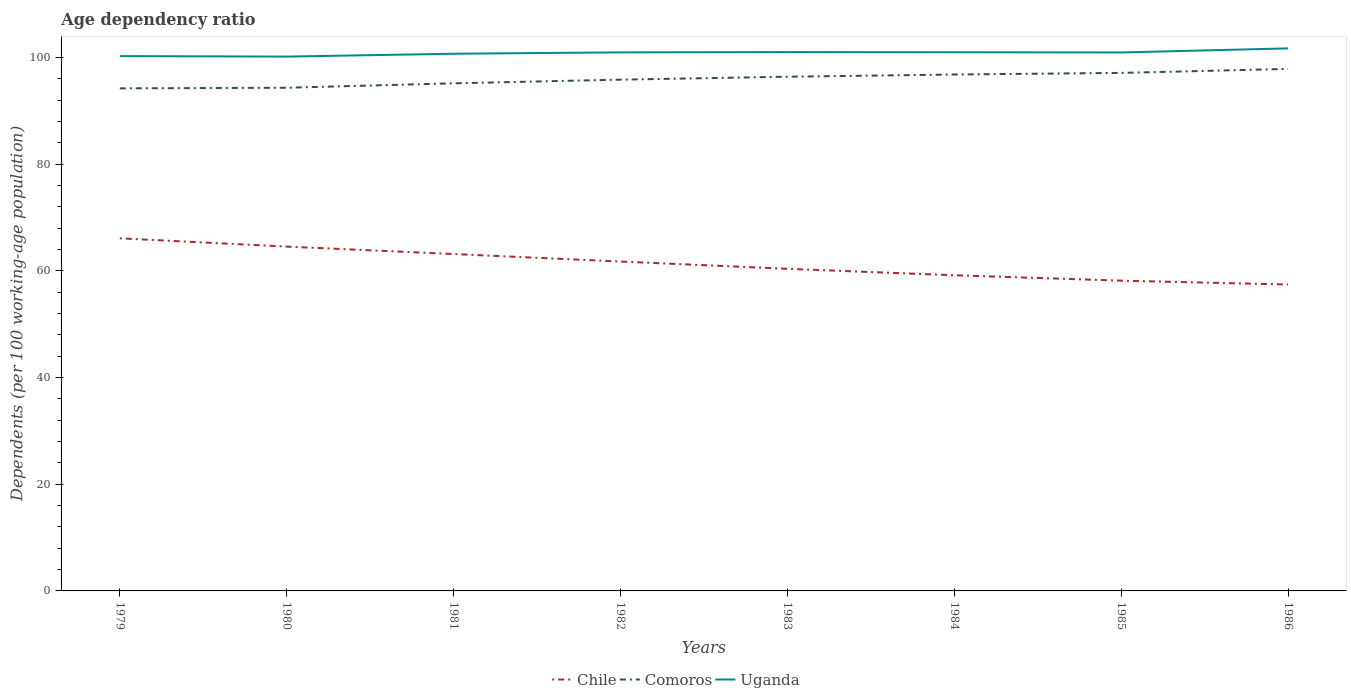Across all years, what is the maximum age dependency ratio in in Comoros?
Provide a succinct answer. 94.24. In which year was the age dependency ratio in in Comoros maximum?
Offer a terse response. 1979. What is the total age dependency ratio in in Chile in the graph?
Your answer should be compact. 4.16. What is the difference between the highest and the second highest age dependency ratio in in Comoros?
Your answer should be very brief. 3.65. How many lines are there?
Make the answer very short. 3. How many years are there in the graph?
Your response must be concise. 8. Does the graph contain grids?
Make the answer very short. No. How many legend labels are there?
Your answer should be very brief. 3. What is the title of the graph?
Make the answer very short. Age dependency ratio. Does "St. Lucia" appear as one of the legend labels in the graph?
Your response must be concise. No. What is the label or title of the X-axis?
Offer a very short reply. Years. What is the label or title of the Y-axis?
Your answer should be compact. Dependents (per 100 working-age population). What is the Dependents (per 100 working-age population) in Chile in 1979?
Your answer should be compact. 66.12. What is the Dependents (per 100 working-age population) of Comoros in 1979?
Keep it short and to the point. 94.24. What is the Dependents (per 100 working-age population) in Uganda in 1979?
Keep it short and to the point. 100.29. What is the Dependents (per 100 working-age population) of Chile in 1980?
Offer a terse response. 64.57. What is the Dependents (per 100 working-age population) in Comoros in 1980?
Keep it short and to the point. 94.36. What is the Dependents (per 100 working-age population) of Uganda in 1980?
Provide a succinct answer. 100.2. What is the Dependents (per 100 working-age population) of Chile in 1981?
Provide a short and direct response. 63.17. What is the Dependents (per 100 working-age population) of Comoros in 1981?
Your response must be concise. 95.18. What is the Dependents (per 100 working-age population) in Uganda in 1981?
Offer a terse response. 100.73. What is the Dependents (per 100 working-age population) of Chile in 1982?
Offer a terse response. 61.76. What is the Dependents (per 100 working-age population) of Comoros in 1982?
Provide a succinct answer. 95.87. What is the Dependents (per 100 working-age population) in Uganda in 1982?
Offer a very short reply. 100.99. What is the Dependents (per 100 working-age population) of Chile in 1983?
Ensure brevity in your answer.  60.4. What is the Dependents (per 100 working-age population) of Comoros in 1983?
Your answer should be very brief. 96.42. What is the Dependents (per 100 working-age population) in Uganda in 1983?
Your answer should be compact. 101.04. What is the Dependents (per 100 working-age population) in Chile in 1984?
Provide a short and direct response. 59.19. What is the Dependents (per 100 working-age population) in Comoros in 1984?
Provide a short and direct response. 96.84. What is the Dependents (per 100 working-age population) of Uganda in 1984?
Your answer should be compact. 101.01. What is the Dependents (per 100 working-age population) in Chile in 1985?
Keep it short and to the point. 58.18. What is the Dependents (per 100 working-age population) in Comoros in 1985?
Make the answer very short. 97.14. What is the Dependents (per 100 working-age population) in Uganda in 1985?
Your answer should be very brief. 100.97. What is the Dependents (per 100 working-age population) in Chile in 1986?
Ensure brevity in your answer.  57.46. What is the Dependents (per 100 working-age population) of Comoros in 1986?
Your response must be concise. 97.89. What is the Dependents (per 100 working-age population) in Uganda in 1986?
Offer a very short reply. 101.74. Across all years, what is the maximum Dependents (per 100 working-age population) in Chile?
Your answer should be compact. 66.12. Across all years, what is the maximum Dependents (per 100 working-age population) in Comoros?
Ensure brevity in your answer.  97.89. Across all years, what is the maximum Dependents (per 100 working-age population) of Uganda?
Ensure brevity in your answer.  101.74. Across all years, what is the minimum Dependents (per 100 working-age population) in Chile?
Keep it short and to the point. 57.46. Across all years, what is the minimum Dependents (per 100 working-age population) in Comoros?
Provide a short and direct response. 94.24. Across all years, what is the minimum Dependents (per 100 working-age population) in Uganda?
Provide a succinct answer. 100.2. What is the total Dependents (per 100 working-age population) in Chile in the graph?
Ensure brevity in your answer.  490.86. What is the total Dependents (per 100 working-age population) of Comoros in the graph?
Provide a succinct answer. 767.94. What is the total Dependents (per 100 working-age population) in Uganda in the graph?
Ensure brevity in your answer.  806.98. What is the difference between the Dependents (per 100 working-age population) in Chile in 1979 and that in 1980?
Provide a succinct answer. 1.55. What is the difference between the Dependents (per 100 working-age population) in Comoros in 1979 and that in 1980?
Ensure brevity in your answer.  -0.12. What is the difference between the Dependents (per 100 working-age population) of Uganda in 1979 and that in 1980?
Make the answer very short. 0.09. What is the difference between the Dependents (per 100 working-age population) of Chile in 1979 and that in 1981?
Offer a terse response. 2.95. What is the difference between the Dependents (per 100 working-age population) in Comoros in 1979 and that in 1981?
Give a very brief answer. -0.95. What is the difference between the Dependents (per 100 working-age population) of Uganda in 1979 and that in 1981?
Your answer should be very brief. -0.44. What is the difference between the Dependents (per 100 working-age population) of Chile in 1979 and that in 1982?
Ensure brevity in your answer.  4.35. What is the difference between the Dependents (per 100 working-age population) in Comoros in 1979 and that in 1982?
Provide a short and direct response. -1.64. What is the difference between the Dependents (per 100 working-age population) of Uganda in 1979 and that in 1982?
Provide a succinct answer. -0.7. What is the difference between the Dependents (per 100 working-age population) in Chile in 1979 and that in 1983?
Keep it short and to the point. 5.72. What is the difference between the Dependents (per 100 working-age population) in Comoros in 1979 and that in 1983?
Your answer should be very brief. -2.18. What is the difference between the Dependents (per 100 working-age population) of Uganda in 1979 and that in 1983?
Ensure brevity in your answer.  -0.75. What is the difference between the Dependents (per 100 working-age population) in Chile in 1979 and that in 1984?
Make the answer very short. 6.93. What is the difference between the Dependents (per 100 working-age population) of Comoros in 1979 and that in 1984?
Your answer should be compact. -2.6. What is the difference between the Dependents (per 100 working-age population) in Uganda in 1979 and that in 1984?
Your response must be concise. -0.72. What is the difference between the Dependents (per 100 working-age population) in Chile in 1979 and that in 1985?
Make the answer very short. 7.94. What is the difference between the Dependents (per 100 working-age population) of Comoros in 1979 and that in 1985?
Your answer should be compact. -2.9. What is the difference between the Dependents (per 100 working-age population) of Uganda in 1979 and that in 1985?
Offer a terse response. -0.68. What is the difference between the Dependents (per 100 working-age population) in Chile in 1979 and that in 1986?
Keep it short and to the point. 8.66. What is the difference between the Dependents (per 100 working-age population) in Comoros in 1979 and that in 1986?
Your answer should be very brief. -3.65. What is the difference between the Dependents (per 100 working-age population) in Uganda in 1979 and that in 1986?
Ensure brevity in your answer.  -1.44. What is the difference between the Dependents (per 100 working-age population) in Chile in 1980 and that in 1981?
Provide a short and direct response. 1.39. What is the difference between the Dependents (per 100 working-age population) in Comoros in 1980 and that in 1981?
Your answer should be compact. -0.83. What is the difference between the Dependents (per 100 working-age population) in Uganda in 1980 and that in 1981?
Make the answer very short. -0.54. What is the difference between the Dependents (per 100 working-age population) in Chile in 1980 and that in 1982?
Your answer should be compact. 2.8. What is the difference between the Dependents (per 100 working-age population) in Comoros in 1980 and that in 1982?
Make the answer very short. -1.52. What is the difference between the Dependents (per 100 working-age population) of Uganda in 1980 and that in 1982?
Offer a very short reply. -0.79. What is the difference between the Dependents (per 100 working-age population) in Chile in 1980 and that in 1983?
Provide a short and direct response. 4.16. What is the difference between the Dependents (per 100 working-age population) of Comoros in 1980 and that in 1983?
Provide a short and direct response. -2.07. What is the difference between the Dependents (per 100 working-age population) in Uganda in 1980 and that in 1983?
Ensure brevity in your answer.  -0.85. What is the difference between the Dependents (per 100 working-age population) of Chile in 1980 and that in 1984?
Make the answer very short. 5.38. What is the difference between the Dependents (per 100 working-age population) in Comoros in 1980 and that in 1984?
Give a very brief answer. -2.48. What is the difference between the Dependents (per 100 working-age population) in Uganda in 1980 and that in 1984?
Offer a terse response. -0.81. What is the difference between the Dependents (per 100 working-age population) in Chile in 1980 and that in 1985?
Your answer should be very brief. 6.39. What is the difference between the Dependents (per 100 working-age population) in Comoros in 1980 and that in 1985?
Offer a very short reply. -2.78. What is the difference between the Dependents (per 100 working-age population) in Uganda in 1980 and that in 1985?
Offer a very short reply. -0.77. What is the difference between the Dependents (per 100 working-age population) in Chile in 1980 and that in 1986?
Your answer should be compact. 7.11. What is the difference between the Dependents (per 100 working-age population) of Comoros in 1980 and that in 1986?
Make the answer very short. -3.53. What is the difference between the Dependents (per 100 working-age population) in Uganda in 1980 and that in 1986?
Give a very brief answer. -1.54. What is the difference between the Dependents (per 100 working-age population) in Chile in 1981 and that in 1982?
Offer a terse response. 1.41. What is the difference between the Dependents (per 100 working-age population) of Comoros in 1981 and that in 1982?
Your response must be concise. -0.69. What is the difference between the Dependents (per 100 working-age population) in Uganda in 1981 and that in 1982?
Provide a short and direct response. -0.25. What is the difference between the Dependents (per 100 working-age population) of Chile in 1981 and that in 1983?
Offer a terse response. 2.77. What is the difference between the Dependents (per 100 working-age population) of Comoros in 1981 and that in 1983?
Offer a terse response. -1.24. What is the difference between the Dependents (per 100 working-age population) of Uganda in 1981 and that in 1983?
Give a very brief answer. -0.31. What is the difference between the Dependents (per 100 working-age population) of Chile in 1981 and that in 1984?
Offer a very short reply. 3.98. What is the difference between the Dependents (per 100 working-age population) in Comoros in 1981 and that in 1984?
Offer a very short reply. -1.65. What is the difference between the Dependents (per 100 working-age population) of Uganda in 1981 and that in 1984?
Provide a succinct answer. -0.28. What is the difference between the Dependents (per 100 working-age population) in Chile in 1981 and that in 1985?
Offer a very short reply. 4.99. What is the difference between the Dependents (per 100 working-age population) in Comoros in 1981 and that in 1985?
Your response must be concise. -1.95. What is the difference between the Dependents (per 100 working-age population) of Uganda in 1981 and that in 1985?
Your response must be concise. -0.24. What is the difference between the Dependents (per 100 working-age population) in Chile in 1981 and that in 1986?
Your response must be concise. 5.72. What is the difference between the Dependents (per 100 working-age population) in Comoros in 1981 and that in 1986?
Provide a short and direct response. -2.7. What is the difference between the Dependents (per 100 working-age population) in Uganda in 1981 and that in 1986?
Keep it short and to the point. -1. What is the difference between the Dependents (per 100 working-age population) of Chile in 1982 and that in 1983?
Your answer should be compact. 1.36. What is the difference between the Dependents (per 100 working-age population) of Comoros in 1982 and that in 1983?
Give a very brief answer. -0.55. What is the difference between the Dependents (per 100 working-age population) of Uganda in 1982 and that in 1983?
Give a very brief answer. -0.06. What is the difference between the Dependents (per 100 working-age population) in Chile in 1982 and that in 1984?
Provide a short and direct response. 2.57. What is the difference between the Dependents (per 100 working-age population) of Comoros in 1982 and that in 1984?
Provide a succinct answer. -0.97. What is the difference between the Dependents (per 100 working-age population) in Uganda in 1982 and that in 1984?
Ensure brevity in your answer.  -0.02. What is the difference between the Dependents (per 100 working-age population) of Chile in 1982 and that in 1985?
Your response must be concise. 3.58. What is the difference between the Dependents (per 100 working-age population) in Comoros in 1982 and that in 1985?
Provide a short and direct response. -1.27. What is the difference between the Dependents (per 100 working-age population) of Uganda in 1982 and that in 1985?
Provide a succinct answer. 0.02. What is the difference between the Dependents (per 100 working-age population) of Chile in 1982 and that in 1986?
Make the answer very short. 4.31. What is the difference between the Dependents (per 100 working-age population) of Comoros in 1982 and that in 1986?
Your answer should be very brief. -2.01. What is the difference between the Dependents (per 100 working-age population) in Uganda in 1982 and that in 1986?
Offer a very short reply. -0.75. What is the difference between the Dependents (per 100 working-age population) in Chile in 1983 and that in 1984?
Ensure brevity in your answer.  1.21. What is the difference between the Dependents (per 100 working-age population) of Comoros in 1983 and that in 1984?
Offer a very short reply. -0.42. What is the difference between the Dependents (per 100 working-age population) in Uganda in 1983 and that in 1984?
Your answer should be compact. 0.03. What is the difference between the Dependents (per 100 working-age population) in Chile in 1983 and that in 1985?
Keep it short and to the point. 2.22. What is the difference between the Dependents (per 100 working-age population) of Comoros in 1983 and that in 1985?
Keep it short and to the point. -0.72. What is the difference between the Dependents (per 100 working-age population) of Uganda in 1983 and that in 1985?
Your answer should be very brief. 0.07. What is the difference between the Dependents (per 100 working-age population) in Chile in 1983 and that in 1986?
Offer a very short reply. 2.95. What is the difference between the Dependents (per 100 working-age population) of Comoros in 1983 and that in 1986?
Ensure brevity in your answer.  -1.47. What is the difference between the Dependents (per 100 working-age population) of Uganda in 1983 and that in 1986?
Your answer should be very brief. -0.69. What is the difference between the Dependents (per 100 working-age population) of Chile in 1984 and that in 1985?
Your response must be concise. 1.01. What is the difference between the Dependents (per 100 working-age population) of Comoros in 1984 and that in 1985?
Make the answer very short. -0.3. What is the difference between the Dependents (per 100 working-age population) in Uganda in 1984 and that in 1985?
Give a very brief answer. 0.04. What is the difference between the Dependents (per 100 working-age population) of Chile in 1984 and that in 1986?
Provide a short and direct response. 1.73. What is the difference between the Dependents (per 100 working-age population) of Comoros in 1984 and that in 1986?
Offer a very short reply. -1.05. What is the difference between the Dependents (per 100 working-age population) of Uganda in 1984 and that in 1986?
Make the answer very short. -0.72. What is the difference between the Dependents (per 100 working-age population) of Chile in 1985 and that in 1986?
Ensure brevity in your answer.  0.72. What is the difference between the Dependents (per 100 working-age population) in Comoros in 1985 and that in 1986?
Make the answer very short. -0.75. What is the difference between the Dependents (per 100 working-age population) of Uganda in 1985 and that in 1986?
Give a very brief answer. -0.76. What is the difference between the Dependents (per 100 working-age population) in Chile in 1979 and the Dependents (per 100 working-age population) in Comoros in 1980?
Ensure brevity in your answer.  -28.24. What is the difference between the Dependents (per 100 working-age population) of Chile in 1979 and the Dependents (per 100 working-age population) of Uganda in 1980?
Your answer should be compact. -34.08. What is the difference between the Dependents (per 100 working-age population) of Comoros in 1979 and the Dependents (per 100 working-age population) of Uganda in 1980?
Your answer should be compact. -5.96. What is the difference between the Dependents (per 100 working-age population) of Chile in 1979 and the Dependents (per 100 working-age population) of Comoros in 1981?
Keep it short and to the point. -29.07. What is the difference between the Dependents (per 100 working-age population) in Chile in 1979 and the Dependents (per 100 working-age population) in Uganda in 1981?
Offer a very short reply. -34.62. What is the difference between the Dependents (per 100 working-age population) in Comoros in 1979 and the Dependents (per 100 working-age population) in Uganda in 1981?
Give a very brief answer. -6.5. What is the difference between the Dependents (per 100 working-age population) in Chile in 1979 and the Dependents (per 100 working-age population) in Comoros in 1982?
Your answer should be compact. -29.75. What is the difference between the Dependents (per 100 working-age population) in Chile in 1979 and the Dependents (per 100 working-age population) in Uganda in 1982?
Provide a succinct answer. -34.87. What is the difference between the Dependents (per 100 working-age population) of Comoros in 1979 and the Dependents (per 100 working-age population) of Uganda in 1982?
Your answer should be compact. -6.75. What is the difference between the Dependents (per 100 working-age population) of Chile in 1979 and the Dependents (per 100 working-age population) of Comoros in 1983?
Provide a succinct answer. -30.3. What is the difference between the Dependents (per 100 working-age population) in Chile in 1979 and the Dependents (per 100 working-age population) in Uganda in 1983?
Your response must be concise. -34.92. What is the difference between the Dependents (per 100 working-age population) of Comoros in 1979 and the Dependents (per 100 working-age population) of Uganda in 1983?
Offer a terse response. -6.81. What is the difference between the Dependents (per 100 working-age population) of Chile in 1979 and the Dependents (per 100 working-age population) of Comoros in 1984?
Make the answer very short. -30.72. What is the difference between the Dependents (per 100 working-age population) in Chile in 1979 and the Dependents (per 100 working-age population) in Uganda in 1984?
Make the answer very short. -34.89. What is the difference between the Dependents (per 100 working-age population) of Comoros in 1979 and the Dependents (per 100 working-age population) of Uganda in 1984?
Give a very brief answer. -6.77. What is the difference between the Dependents (per 100 working-age population) of Chile in 1979 and the Dependents (per 100 working-age population) of Comoros in 1985?
Keep it short and to the point. -31.02. What is the difference between the Dependents (per 100 working-age population) of Chile in 1979 and the Dependents (per 100 working-age population) of Uganda in 1985?
Offer a very short reply. -34.85. What is the difference between the Dependents (per 100 working-age population) in Comoros in 1979 and the Dependents (per 100 working-age population) in Uganda in 1985?
Give a very brief answer. -6.73. What is the difference between the Dependents (per 100 working-age population) in Chile in 1979 and the Dependents (per 100 working-age population) in Comoros in 1986?
Make the answer very short. -31.77. What is the difference between the Dependents (per 100 working-age population) in Chile in 1979 and the Dependents (per 100 working-age population) in Uganda in 1986?
Offer a terse response. -35.62. What is the difference between the Dependents (per 100 working-age population) in Comoros in 1979 and the Dependents (per 100 working-age population) in Uganda in 1986?
Ensure brevity in your answer.  -7.5. What is the difference between the Dependents (per 100 working-age population) in Chile in 1980 and the Dependents (per 100 working-age population) in Comoros in 1981?
Your answer should be compact. -30.62. What is the difference between the Dependents (per 100 working-age population) in Chile in 1980 and the Dependents (per 100 working-age population) in Uganda in 1981?
Ensure brevity in your answer.  -36.17. What is the difference between the Dependents (per 100 working-age population) in Comoros in 1980 and the Dependents (per 100 working-age population) in Uganda in 1981?
Your answer should be very brief. -6.38. What is the difference between the Dependents (per 100 working-age population) in Chile in 1980 and the Dependents (per 100 working-age population) in Comoros in 1982?
Provide a short and direct response. -31.31. What is the difference between the Dependents (per 100 working-age population) of Chile in 1980 and the Dependents (per 100 working-age population) of Uganda in 1982?
Make the answer very short. -36.42. What is the difference between the Dependents (per 100 working-age population) in Comoros in 1980 and the Dependents (per 100 working-age population) in Uganda in 1982?
Your response must be concise. -6.63. What is the difference between the Dependents (per 100 working-age population) of Chile in 1980 and the Dependents (per 100 working-age population) of Comoros in 1983?
Offer a terse response. -31.85. What is the difference between the Dependents (per 100 working-age population) of Chile in 1980 and the Dependents (per 100 working-age population) of Uganda in 1983?
Make the answer very short. -36.48. What is the difference between the Dependents (per 100 working-age population) in Comoros in 1980 and the Dependents (per 100 working-age population) in Uganda in 1983?
Your response must be concise. -6.69. What is the difference between the Dependents (per 100 working-age population) of Chile in 1980 and the Dependents (per 100 working-age population) of Comoros in 1984?
Give a very brief answer. -32.27. What is the difference between the Dependents (per 100 working-age population) in Chile in 1980 and the Dependents (per 100 working-age population) in Uganda in 1984?
Give a very brief answer. -36.44. What is the difference between the Dependents (per 100 working-age population) of Comoros in 1980 and the Dependents (per 100 working-age population) of Uganda in 1984?
Provide a short and direct response. -6.66. What is the difference between the Dependents (per 100 working-age population) in Chile in 1980 and the Dependents (per 100 working-age population) in Comoros in 1985?
Make the answer very short. -32.57. What is the difference between the Dependents (per 100 working-age population) of Chile in 1980 and the Dependents (per 100 working-age population) of Uganda in 1985?
Your answer should be compact. -36.4. What is the difference between the Dependents (per 100 working-age population) of Comoros in 1980 and the Dependents (per 100 working-age population) of Uganda in 1985?
Provide a short and direct response. -6.62. What is the difference between the Dependents (per 100 working-age population) in Chile in 1980 and the Dependents (per 100 working-age population) in Comoros in 1986?
Ensure brevity in your answer.  -33.32. What is the difference between the Dependents (per 100 working-age population) of Chile in 1980 and the Dependents (per 100 working-age population) of Uganda in 1986?
Keep it short and to the point. -37.17. What is the difference between the Dependents (per 100 working-age population) of Comoros in 1980 and the Dependents (per 100 working-age population) of Uganda in 1986?
Give a very brief answer. -7.38. What is the difference between the Dependents (per 100 working-age population) of Chile in 1981 and the Dependents (per 100 working-age population) of Comoros in 1982?
Your answer should be compact. -32.7. What is the difference between the Dependents (per 100 working-age population) of Chile in 1981 and the Dependents (per 100 working-age population) of Uganda in 1982?
Offer a very short reply. -37.82. What is the difference between the Dependents (per 100 working-age population) of Comoros in 1981 and the Dependents (per 100 working-age population) of Uganda in 1982?
Ensure brevity in your answer.  -5.8. What is the difference between the Dependents (per 100 working-age population) of Chile in 1981 and the Dependents (per 100 working-age population) of Comoros in 1983?
Your answer should be compact. -33.25. What is the difference between the Dependents (per 100 working-age population) of Chile in 1981 and the Dependents (per 100 working-age population) of Uganda in 1983?
Offer a very short reply. -37.87. What is the difference between the Dependents (per 100 working-age population) in Comoros in 1981 and the Dependents (per 100 working-age population) in Uganda in 1983?
Ensure brevity in your answer.  -5.86. What is the difference between the Dependents (per 100 working-age population) in Chile in 1981 and the Dependents (per 100 working-age population) in Comoros in 1984?
Your answer should be compact. -33.67. What is the difference between the Dependents (per 100 working-age population) in Chile in 1981 and the Dependents (per 100 working-age population) in Uganda in 1984?
Offer a terse response. -37.84. What is the difference between the Dependents (per 100 working-age population) of Comoros in 1981 and the Dependents (per 100 working-age population) of Uganda in 1984?
Keep it short and to the point. -5.83. What is the difference between the Dependents (per 100 working-age population) in Chile in 1981 and the Dependents (per 100 working-age population) in Comoros in 1985?
Ensure brevity in your answer.  -33.97. What is the difference between the Dependents (per 100 working-age population) in Chile in 1981 and the Dependents (per 100 working-age population) in Uganda in 1985?
Keep it short and to the point. -37.8. What is the difference between the Dependents (per 100 working-age population) of Comoros in 1981 and the Dependents (per 100 working-age population) of Uganda in 1985?
Provide a succinct answer. -5.79. What is the difference between the Dependents (per 100 working-age population) in Chile in 1981 and the Dependents (per 100 working-age population) in Comoros in 1986?
Your response must be concise. -34.72. What is the difference between the Dependents (per 100 working-age population) of Chile in 1981 and the Dependents (per 100 working-age population) of Uganda in 1986?
Your response must be concise. -38.56. What is the difference between the Dependents (per 100 working-age population) of Comoros in 1981 and the Dependents (per 100 working-age population) of Uganda in 1986?
Provide a succinct answer. -6.55. What is the difference between the Dependents (per 100 working-age population) in Chile in 1982 and the Dependents (per 100 working-age population) in Comoros in 1983?
Provide a succinct answer. -34.66. What is the difference between the Dependents (per 100 working-age population) of Chile in 1982 and the Dependents (per 100 working-age population) of Uganda in 1983?
Your answer should be very brief. -39.28. What is the difference between the Dependents (per 100 working-age population) in Comoros in 1982 and the Dependents (per 100 working-age population) in Uganda in 1983?
Your response must be concise. -5.17. What is the difference between the Dependents (per 100 working-age population) in Chile in 1982 and the Dependents (per 100 working-age population) in Comoros in 1984?
Provide a succinct answer. -35.07. What is the difference between the Dependents (per 100 working-age population) of Chile in 1982 and the Dependents (per 100 working-age population) of Uganda in 1984?
Ensure brevity in your answer.  -39.25. What is the difference between the Dependents (per 100 working-age population) of Comoros in 1982 and the Dependents (per 100 working-age population) of Uganda in 1984?
Offer a very short reply. -5.14. What is the difference between the Dependents (per 100 working-age population) in Chile in 1982 and the Dependents (per 100 working-age population) in Comoros in 1985?
Provide a short and direct response. -35.37. What is the difference between the Dependents (per 100 working-age population) in Chile in 1982 and the Dependents (per 100 working-age population) in Uganda in 1985?
Your response must be concise. -39.21. What is the difference between the Dependents (per 100 working-age population) of Comoros in 1982 and the Dependents (per 100 working-age population) of Uganda in 1985?
Provide a short and direct response. -5.1. What is the difference between the Dependents (per 100 working-age population) in Chile in 1982 and the Dependents (per 100 working-age population) in Comoros in 1986?
Give a very brief answer. -36.12. What is the difference between the Dependents (per 100 working-age population) of Chile in 1982 and the Dependents (per 100 working-age population) of Uganda in 1986?
Ensure brevity in your answer.  -39.97. What is the difference between the Dependents (per 100 working-age population) in Comoros in 1982 and the Dependents (per 100 working-age population) in Uganda in 1986?
Offer a very short reply. -5.86. What is the difference between the Dependents (per 100 working-age population) of Chile in 1983 and the Dependents (per 100 working-age population) of Comoros in 1984?
Your response must be concise. -36.44. What is the difference between the Dependents (per 100 working-age population) in Chile in 1983 and the Dependents (per 100 working-age population) in Uganda in 1984?
Make the answer very short. -40.61. What is the difference between the Dependents (per 100 working-age population) of Comoros in 1983 and the Dependents (per 100 working-age population) of Uganda in 1984?
Give a very brief answer. -4.59. What is the difference between the Dependents (per 100 working-age population) in Chile in 1983 and the Dependents (per 100 working-age population) in Comoros in 1985?
Offer a very short reply. -36.73. What is the difference between the Dependents (per 100 working-age population) in Chile in 1983 and the Dependents (per 100 working-age population) in Uganda in 1985?
Provide a short and direct response. -40.57. What is the difference between the Dependents (per 100 working-age population) of Comoros in 1983 and the Dependents (per 100 working-age population) of Uganda in 1985?
Ensure brevity in your answer.  -4.55. What is the difference between the Dependents (per 100 working-age population) of Chile in 1983 and the Dependents (per 100 working-age population) of Comoros in 1986?
Ensure brevity in your answer.  -37.48. What is the difference between the Dependents (per 100 working-age population) of Chile in 1983 and the Dependents (per 100 working-age population) of Uganda in 1986?
Offer a terse response. -41.33. What is the difference between the Dependents (per 100 working-age population) of Comoros in 1983 and the Dependents (per 100 working-age population) of Uganda in 1986?
Offer a terse response. -5.31. What is the difference between the Dependents (per 100 working-age population) of Chile in 1984 and the Dependents (per 100 working-age population) of Comoros in 1985?
Your answer should be very brief. -37.95. What is the difference between the Dependents (per 100 working-age population) of Chile in 1984 and the Dependents (per 100 working-age population) of Uganda in 1985?
Give a very brief answer. -41.78. What is the difference between the Dependents (per 100 working-age population) in Comoros in 1984 and the Dependents (per 100 working-age population) in Uganda in 1985?
Provide a succinct answer. -4.13. What is the difference between the Dependents (per 100 working-age population) of Chile in 1984 and the Dependents (per 100 working-age population) of Comoros in 1986?
Give a very brief answer. -38.7. What is the difference between the Dependents (per 100 working-age population) of Chile in 1984 and the Dependents (per 100 working-age population) of Uganda in 1986?
Provide a succinct answer. -42.55. What is the difference between the Dependents (per 100 working-age population) in Comoros in 1984 and the Dependents (per 100 working-age population) in Uganda in 1986?
Provide a short and direct response. -4.9. What is the difference between the Dependents (per 100 working-age population) in Chile in 1985 and the Dependents (per 100 working-age population) in Comoros in 1986?
Your response must be concise. -39.71. What is the difference between the Dependents (per 100 working-age population) in Chile in 1985 and the Dependents (per 100 working-age population) in Uganda in 1986?
Your response must be concise. -43.56. What is the difference between the Dependents (per 100 working-age population) in Comoros in 1985 and the Dependents (per 100 working-age population) in Uganda in 1986?
Offer a very short reply. -4.6. What is the average Dependents (per 100 working-age population) in Chile per year?
Provide a succinct answer. 61.36. What is the average Dependents (per 100 working-age population) in Comoros per year?
Your answer should be very brief. 95.99. What is the average Dependents (per 100 working-age population) in Uganda per year?
Offer a terse response. 100.87. In the year 1979, what is the difference between the Dependents (per 100 working-age population) of Chile and Dependents (per 100 working-age population) of Comoros?
Make the answer very short. -28.12. In the year 1979, what is the difference between the Dependents (per 100 working-age population) in Chile and Dependents (per 100 working-age population) in Uganda?
Your answer should be compact. -34.17. In the year 1979, what is the difference between the Dependents (per 100 working-age population) in Comoros and Dependents (per 100 working-age population) in Uganda?
Ensure brevity in your answer.  -6.05. In the year 1980, what is the difference between the Dependents (per 100 working-age population) of Chile and Dependents (per 100 working-age population) of Comoros?
Keep it short and to the point. -29.79. In the year 1980, what is the difference between the Dependents (per 100 working-age population) of Chile and Dependents (per 100 working-age population) of Uganda?
Provide a short and direct response. -35.63. In the year 1980, what is the difference between the Dependents (per 100 working-age population) of Comoros and Dependents (per 100 working-age population) of Uganda?
Provide a succinct answer. -5.84. In the year 1981, what is the difference between the Dependents (per 100 working-age population) of Chile and Dependents (per 100 working-age population) of Comoros?
Offer a very short reply. -32.01. In the year 1981, what is the difference between the Dependents (per 100 working-age population) in Chile and Dependents (per 100 working-age population) in Uganda?
Keep it short and to the point. -37.56. In the year 1981, what is the difference between the Dependents (per 100 working-age population) of Comoros and Dependents (per 100 working-age population) of Uganda?
Provide a short and direct response. -5.55. In the year 1982, what is the difference between the Dependents (per 100 working-age population) in Chile and Dependents (per 100 working-age population) in Comoros?
Ensure brevity in your answer.  -34.11. In the year 1982, what is the difference between the Dependents (per 100 working-age population) of Chile and Dependents (per 100 working-age population) of Uganda?
Offer a very short reply. -39.22. In the year 1982, what is the difference between the Dependents (per 100 working-age population) of Comoros and Dependents (per 100 working-age population) of Uganda?
Make the answer very short. -5.11. In the year 1983, what is the difference between the Dependents (per 100 working-age population) of Chile and Dependents (per 100 working-age population) of Comoros?
Make the answer very short. -36.02. In the year 1983, what is the difference between the Dependents (per 100 working-age population) of Chile and Dependents (per 100 working-age population) of Uganda?
Ensure brevity in your answer.  -40.64. In the year 1983, what is the difference between the Dependents (per 100 working-age population) of Comoros and Dependents (per 100 working-age population) of Uganda?
Make the answer very short. -4.62. In the year 1984, what is the difference between the Dependents (per 100 working-age population) of Chile and Dependents (per 100 working-age population) of Comoros?
Offer a very short reply. -37.65. In the year 1984, what is the difference between the Dependents (per 100 working-age population) in Chile and Dependents (per 100 working-age population) in Uganda?
Keep it short and to the point. -41.82. In the year 1984, what is the difference between the Dependents (per 100 working-age population) in Comoros and Dependents (per 100 working-age population) in Uganda?
Give a very brief answer. -4.17. In the year 1985, what is the difference between the Dependents (per 100 working-age population) of Chile and Dependents (per 100 working-age population) of Comoros?
Your answer should be very brief. -38.96. In the year 1985, what is the difference between the Dependents (per 100 working-age population) in Chile and Dependents (per 100 working-age population) in Uganda?
Make the answer very short. -42.79. In the year 1985, what is the difference between the Dependents (per 100 working-age population) in Comoros and Dependents (per 100 working-age population) in Uganda?
Provide a short and direct response. -3.83. In the year 1986, what is the difference between the Dependents (per 100 working-age population) in Chile and Dependents (per 100 working-age population) in Comoros?
Offer a very short reply. -40.43. In the year 1986, what is the difference between the Dependents (per 100 working-age population) in Chile and Dependents (per 100 working-age population) in Uganda?
Provide a succinct answer. -44.28. In the year 1986, what is the difference between the Dependents (per 100 working-age population) in Comoros and Dependents (per 100 working-age population) in Uganda?
Offer a terse response. -3.85. What is the ratio of the Dependents (per 100 working-age population) of Chile in 1979 to that in 1980?
Provide a short and direct response. 1.02. What is the ratio of the Dependents (per 100 working-age population) in Uganda in 1979 to that in 1980?
Offer a very short reply. 1. What is the ratio of the Dependents (per 100 working-age population) of Chile in 1979 to that in 1981?
Your answer should be very brief. 1.05. What is the ratio of the Dependents (per 100 working-age population) in Uganda in 1979 to that in 1981?
Provide a succinct answer. 1. What is the ratio of the Dependents (per 100 working-age population) in Chile in 1979 to that in 1982?
Keep it short and to the point. 1.07. What is the ratio of the Dependents (per 100 working-age population) of Comoros in 1979 to that in 1982?
Ensure brevity in your answer.  0.98. What is the ratio of the Dependents (per 100 working-age population) of Uganda in 1979 to that in 1982?
Provide a succinct answer. 0.99. What is the ratio of the Dependents (per 100 working-age population) in Chile in 1979 to that in 1983?
Offer a terse response. 1.09. What is the ratio of the Dependents (per 100 working-age population) in Comoros in 1979 to that in 1983?
Ensure brevity in your answer.  0.98. What is the ratio of the Dependents (per 100 working-age population) of Chile in 1979 to that in 1984?
Make the answer very short. 1.12. What is the ratio of the Dependents (per 100 working-age population) in Comoros in 1979 to that in 1984?
Your answer should be very brief. 0.97. What is the ratio of the Dependents (per 100 working-age population) in Uganda in 1979 to that in 1984?
Keep it short and to the point. 0.99. What is the ratio of the Dependents (per 100 working-age population) in Chile in 1979 to that in 1985?
Provide a short and direct response. 1.14. What is the ratio of the Dependents (per 100 working-age population) of Comoros in 1979 to that in 1985?
Your answer should be compact. 0.97. What is the ratio of the Dependents (per 100 working-age population) in Uganda in 1979 to that in 1985?
Ensure brevity in your answer.  0.99. What is the ratio of the Dependents (per 100 working-age population) in Chile in 1979 to that in 1986?
Your answer should be very brief. 1.15. What is the ratio of the Dependents (per 100 working-age population) in Comoros in 1979 to that in 1986?
Ensure brevity in your answer.  0.96. What is the ratio of the Dependents (per 100 working-age population) in Uganda in 1979 to that in 1986?
Make the answer very short. 0.99. What is the ratio of the Dependents (per 100 working-age population) of Chile in 1980 to that in 1981?
Provide a succinct answer. 1.02. What is the ratio of the Dependents (per 100 working-age population) in Chile in 1980 to that in 1982?
Provide a succinct answer. 1.05. What is the ratio of the Dependents (per 100 working-age population) in Comoros in 1980 to that in 1982?
Your answer should be compact. 0.98. What is the ratio of the Dependents (per 100 working-age population) of Chile in 1980 to that in 1983?
Provide a succinct answer. 1.07. What is the ratio of the Dependents (per 100 working-age population) of Comoros in 1980 to that in 1983?
Make the answer very short. 0.98. What is the ratio of the Dependents (per 100 working-age population) of Chile in 1980 to that in 1984?
Your answer should be compact. 1.09. What is the ratio of the Dependents (per 100 working-age population) in Comoros in 1980 to that in 1984?
Offer a terse response. 0.97. What is the ratio of the Dependents (per 100 working-age population) in Uganda in 1980 to that in 1984?
Give a very brief answer. 0.99. What is the ratio of the Dependents (per 100 working-age population) of Chile in 1980 to that in 1985?
Provide a short and direct response. 1.11. What is the ratio of the Dependents (per 100 working-age population) of Comoros in 1980 to that in 1985?
Keep it short and to the point. 0.97. What is the ratio of the Dependents (per 100 working-age population) in Chile in 1980 to that in 1986?
Give a very brief answer. 1.12. What is the ratio of the Dependents (per 100 working-age population) in Comoros in 1980 to that in 1986?
Your response must be concise. 0.96. What is the ratio of the Dependents (per 100 working-age population) in Uganda in 1980 to that in 1986?
Provide a succinct answer. 0.98. What is the ratio of the Dependents (per 100 working-age population) of Chile in 1981 to that in 1982?
Offer a terse response. 1.02. What is the ratio of the Dependents (per 100 working-age population) in Chile in 1981 to that in 1983?
Provide a succinct answer. 1.05. What is the ratio of the Dependents (per 100 working-age population) of Comoros in 1981 to that in 1983?
Offer a very short reply. 0.99. What is the ratio of the Dependents (per 100 working-age population) of Chile in 1981 to that in 1984?
Provide a short and direct response. 1.07. What is the ratio of the Dependents (per 100 working-age population) of Comoros in 1981 to that in 1984?
Your answer should be compact. 0.98. What is the ratio of the Dependents (per 100 working-age population) of Uganda in 1981 to that in 1984?
Make the answer very short. 1. What is the ratio of the Dependents (per 100 working-age population) of Chile in 1981 to that in 1985?
Your response must be concise. 1.09. What is the ratio of the Dependents (per 100 working-age population) in Comoros in 1981 to that in 1985?
Ensure brevity in your answer.  0.98. What is the ratio of the Dependents (per 100 working-age population) of Chile in 1981 to that in 1986?
Offer a terse response. 1.1. What is the ratio of the Dependents (per 100 working-age population) in Comoros in 1981 to that in 1986?
Give a very brief answer. 0.97. What is the ratio of the Dependents (per 100 working-age population) in Chile in 1982 to that in 1983?
Your answer should be compact. 1.02. What is the ratio of the Dependents (per 100 working-age population) of Chile in 1982 to that in 1984?
Provide a succinct answer. 1.04. What is the ratio of the Dependents (per 100 working-age population) of Comoros in 1982 to that in 1984?
Offer a terse response. 0.99. What is the ratio of the Dependents (per 100 working-age population) of Uganda in 1982 to that in 1984?
Offer a terse response. 1. What is the ratio of the Dependents (per 100 working-age population) of Chile in 1982 to that in 1985?
Offer a terse response. 1.06. What is the ratio of the Dependents (per 100 working-age population) of Uganda in 1982 to that in 1985?
Your response must be concise. 1. What is the ratio of the Dependents (per 100 working-age population) of Chile in 1982 to that in 1986?
Your answer should be compact. 1.07. What is the ratio of the Dependents (per 100 working-age population) in Comoros in 1982 to that in 1986?
Your answer should be compact. 0.98. What is the ratio of the Dependents (per 100 working-age population) in Chile in 1983 to that in 1984?
Your answer should be very brief. 1.02. What is the ratio of the Dependents (per 100 working-age population) of Comoros in 1983 to that in 1984?
Ensure brevity in your answer.  1. What is the ratio of the Dependents (per 100 working-age population) in Uganda in 1983 to that in 1984?
Your answer should be very brief. 1. What is the ratio of the Dependents (per 100 working-age population) in Chile in 1983 to that in 1985?
Make the answer very short. 1.04. What is the ratio of the Dependents (per 100 working-age population) in Comoros in 1983 to that in 1985?
Keep it short and to the point. 0.99. What is the ratio of the Dependents (per 100 working-age population) in Uganda in 1983 to that in 1985?
Keep it short and to the point. 1. What is the ratio of the Dependents (per 100 working-age population) of Chile in 1983 to that in 1986?
Offer a very short reply. 1.05. What is the ratio of the Dependents (per 100 working-age population) of Comoros in 1983 to that in 1986?
Give a very brief answer. 0.98. What is the ratio of the Dependents (per 100 working-age population) in Uganda in 1983 to that in 1986?
Provide a short and direct response. 0.99. What is the ratio of the Dependents (per 100 working-age population) in Chile in 1984 to that in 1985?
Keep it short and to the point. 1.02. What is the ratio of the Dependents (per 100 working-age population) in Comoros in 1984 to that in 1985?
Ensure brevity in your answer.  1. What is the ratio of the Dependents (per 100 working-age population) in Chile in 1984 to that in 1986?
Your answer should be very brief. 1.03. What is the ratio of the Dependents (per 100 working-age population) in Comoros in 1984 to that in 1986?
Your response must be concise. 0.99. What is the ratio of the Dependents (per 100 working-age population) of Chile in 1985 to that in 1986?
Offer a very short reply. 1.01. What is the difference between the highest and the second highest Dependents (per 100 working-age population) in Chile?
Make the answer very short. 1.55. What is the difference between the highest and the second highest Dependents (per 100 working-age population) of Comoros?
Give a very brief answer. 0.75. What is the difference between the highest and the second highest Dependents (per 100 working-age population) in Uganda?
Keep it short and to the point. 0.69. What is the difference between the highest and the lowest Dependents (per 100 working-age population) in Chile?
Offer a very short reply. 8.66. What is the difference between the highest and the lowest Dependents (per 100 working-age population) of Comoros?
Your answer should be very brief. 3.65. What is the difference between the highest and the lowest Dependents (per 100 working-age population) of Uganda?
Ensure brevity in your answer.  1.54. 